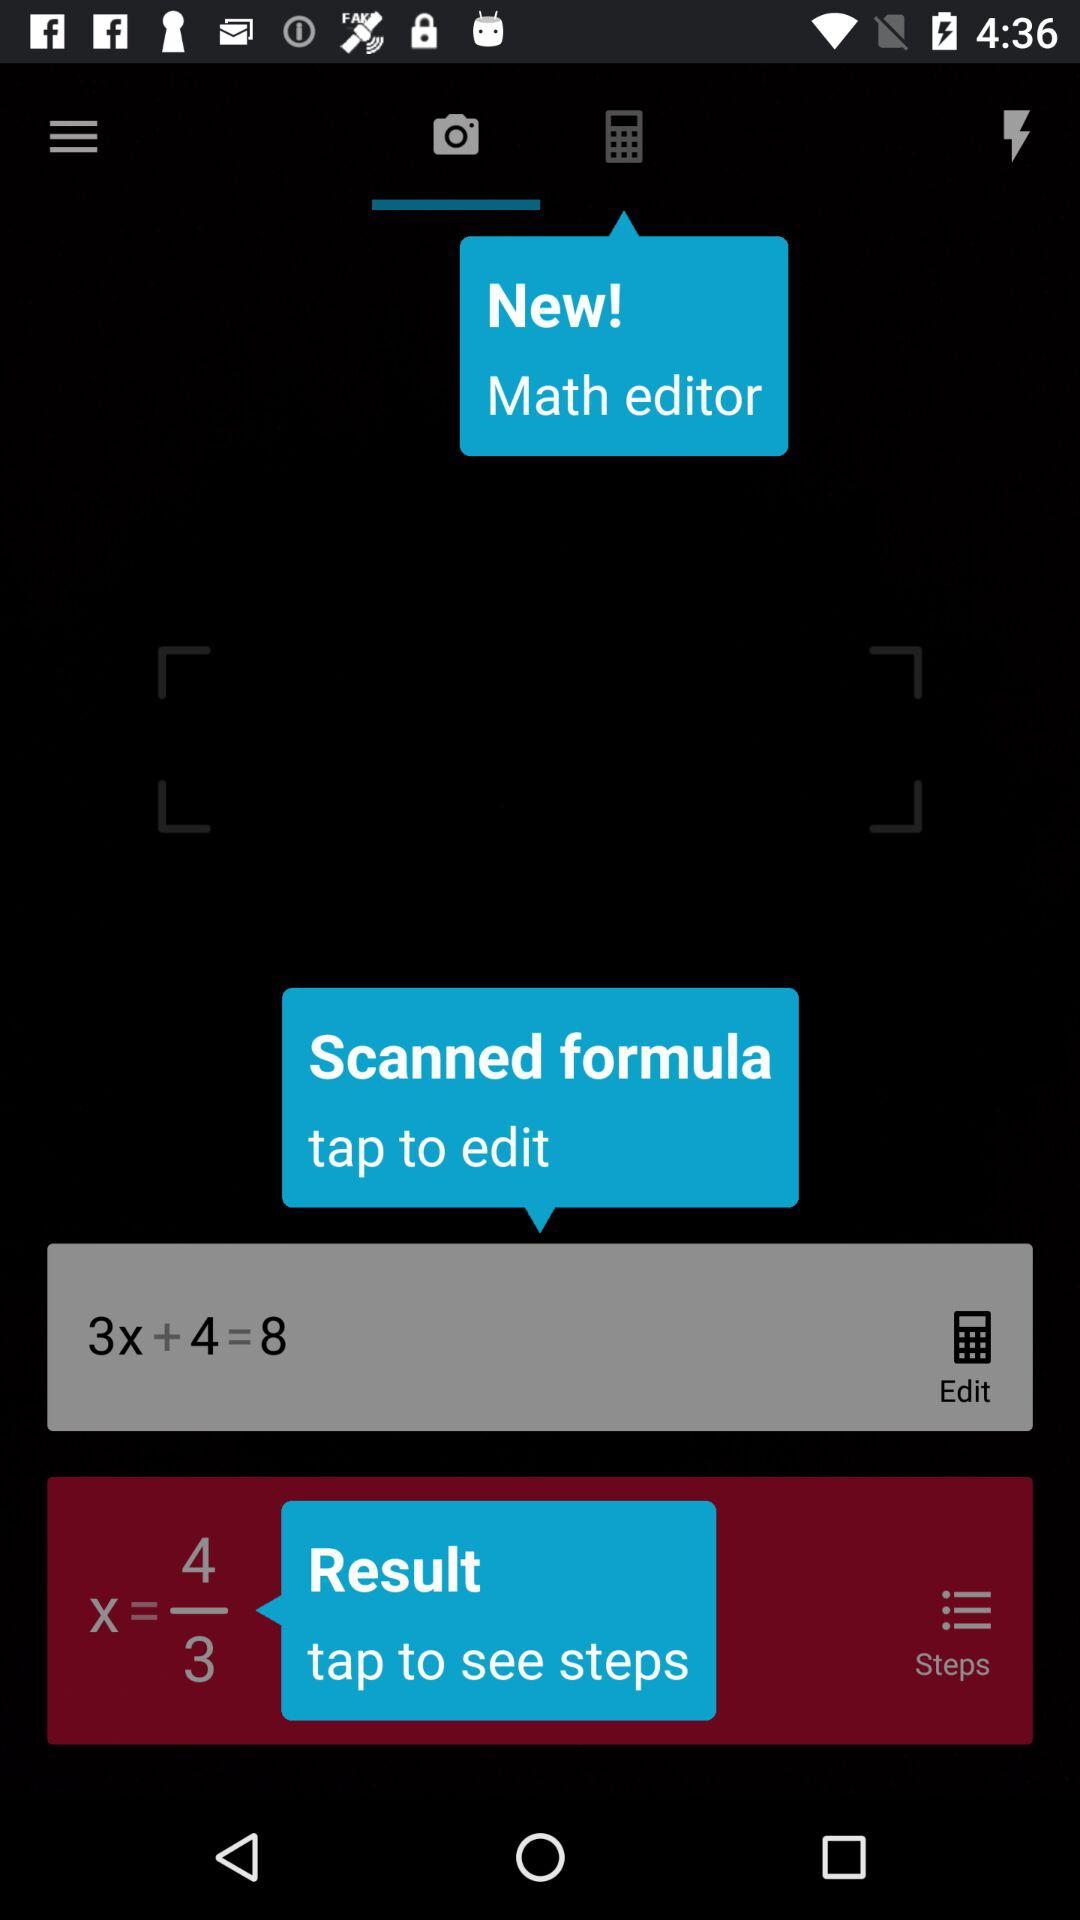Which tab is selected? The selected tab is "Camera". 